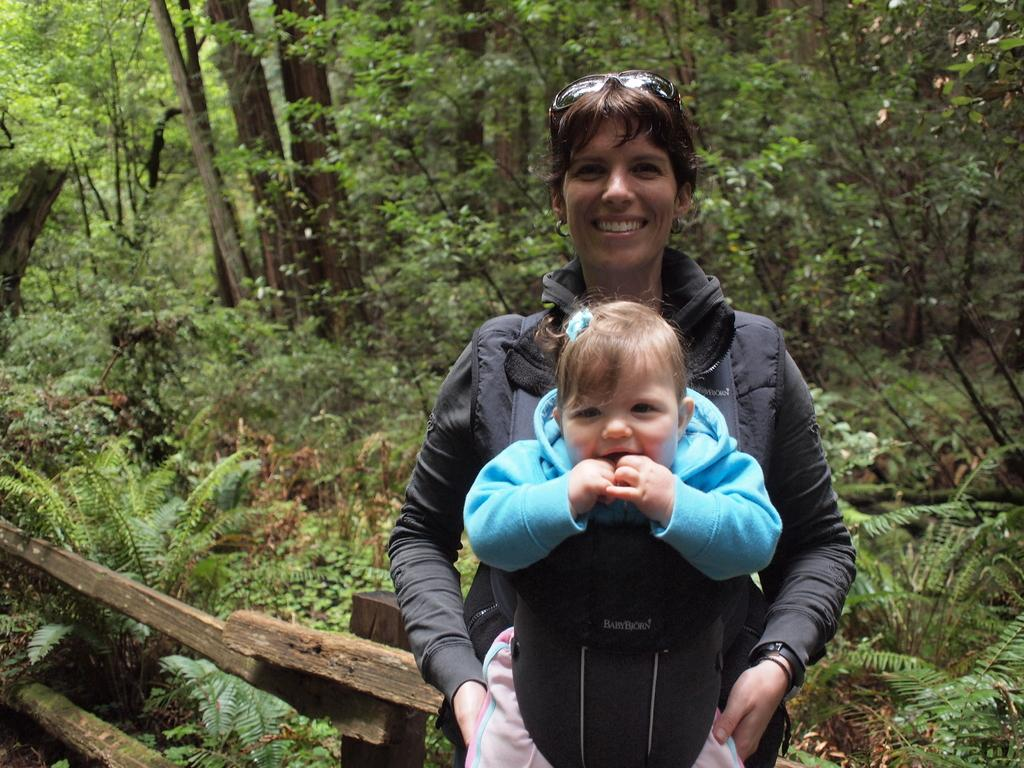Who is the main subject in the image? There is a woman in the image. What is the woman doing in the image? The woman is carrying a baby. What can be seen in the background of the image? Trees and grass are visible in the background of the image. What type of cord is being used by the woman to talk to the baby in the image? There is no cord or communication device visible in the image; the woman is simply carrying the baby. 